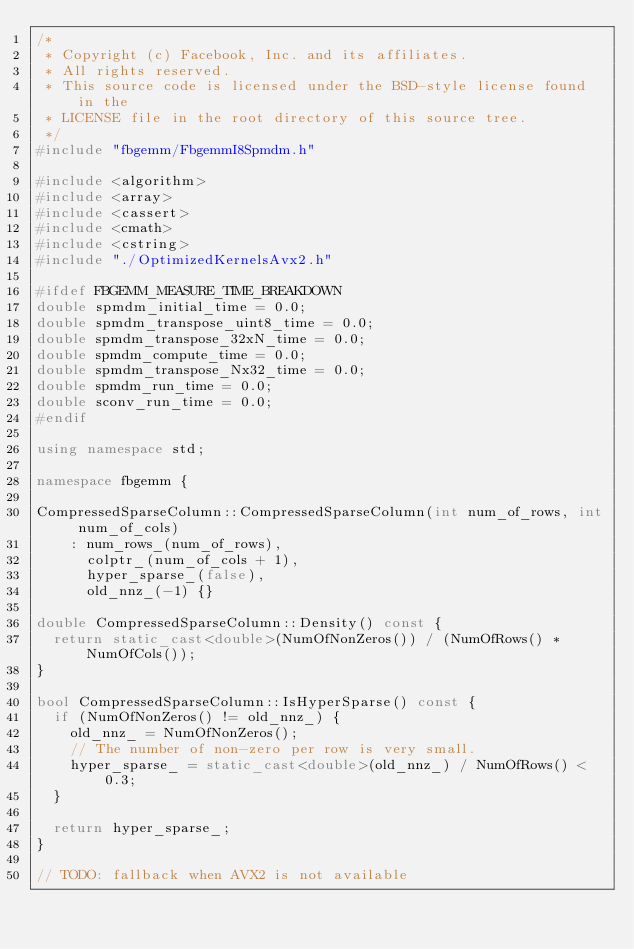Convert code to text. <code><loc_0><loc_0><loc_500><loc_500><_C++_>/*
 * Copyright (c) Facebook, Inc. and its affiliates.
 * All rights reserved.
 * This source code is licensed under the BSD-style license found in the
 * LICENSE file in the root directory of this source tree.
 */
#include "fbgemm/FbgemmI8Spmdm.h"

#include <algorithm>
#include <array>
#include <cassert>
#include <cmath>
#include <cstring>
#include "./OptimizedKernelsAvx2.h"

#ifdef FBGEMM_MEASURE_TIME_BREAKDOWN
double spmdm_initial_time = 0.0;
double spmdm_transpose_uint8_time = 0.0;
double spmdm_transpose_32xN_time = 0.0;
double spmdm_compute_time = 0.0;
double spmdm_transpose_Nx32_time = 0.0;
double spmdm_run_time = 0.0;
double sconv_run_time = 0.0;
#endif

using namespace std;

namespace fbgemm {

CompressedSparseColumn::CompressedSparseColumn(int num_of_rows, int num_of_cols)
    : num_rows_(num_of_rows),
      colptr_(num_of_cols + 1),
      hyper_sparse_(false),
      old_nnz_(-1) {}

double CompressedSparseColumn::Density() const {
  return static_cast<double>(NumOfNonZeros()) / (NumOfRows() * NumOfCols());
}

bool CompressedSparseColumn::IsHyperSparse() const {
  if (NumOfNonZeros() != old_nnz_) {
    old_nnz_ = NumOfNonZeros();
    // The number of non-zero per row is very small.
    hyper_sparse_ = static_cast<double>(old_nnz_) / NumOfRows() < 0.3;
  }

  return hyper_sparse_;
}

// TODO: fallback when AVX2 is not available</code> 